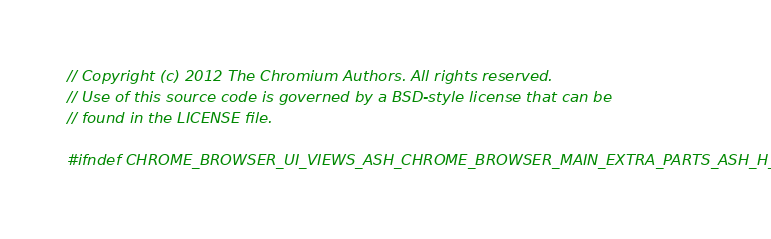<code> <loc_0><loc_0><loc_500><loc_500><_C_>// Copyright (c) 2012 The Chromium Authors. All rights reserved.
// Use of this source code is governed by a BSD-style license that can be
// found in the LICENSE file.

#ifndef CHROME_BROWSER_UI_VIEWS_ASH_CHROME_BROWSER_MAIN_EXTRA_PARTS_ASH_H_</code> 